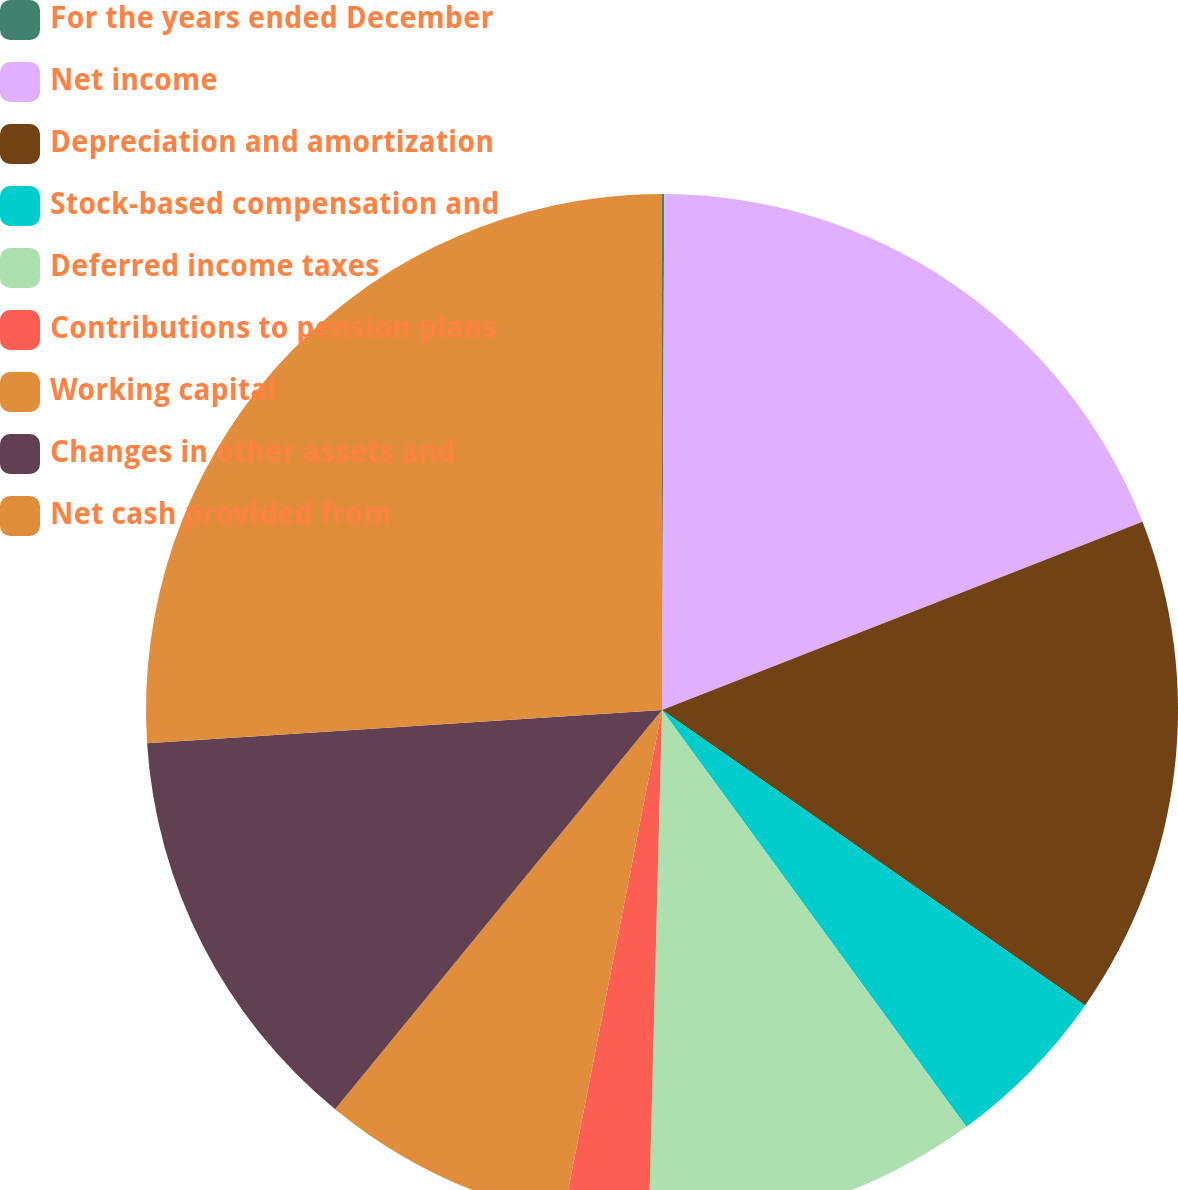<chart> <loc_0><loc_0><loc_500><loc_500><pie_chart><fcel>For the years ended December<fcel>Net income<fcel>Depreciation and amortization<fcel>Stock-based compensation and<fcel>Deferred income taxes<fcel>Contributions to pension plans<fcel>Working capital<fcel>Changes in other assets and<fcel>Net cash provided from<nl><fcel>0.07%<fcel>18.99%<fcel>15.64%<fcel>5.26%<fcel>10.45%<fcel>2.66%<fcel>7.85%<fcel>13.05%<fcel>26.03%<nl></chart> 